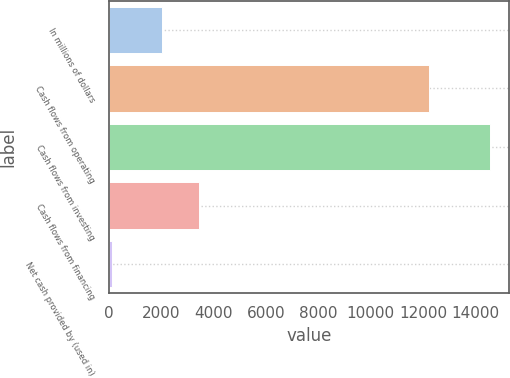<chart> <loc_0><loc_0><loc_500><loc_500><bar_chart><fcel>In millions of dollars<fcel>Cash flows from operating<fcel>Cash flows from investing<fcel>Cash flows from financing<fcel>Net cash provided by (used in)<nl><fcel>2007<fcel>12248<fcel>14581<fcel>3453<fcel>121<nl></chart> 